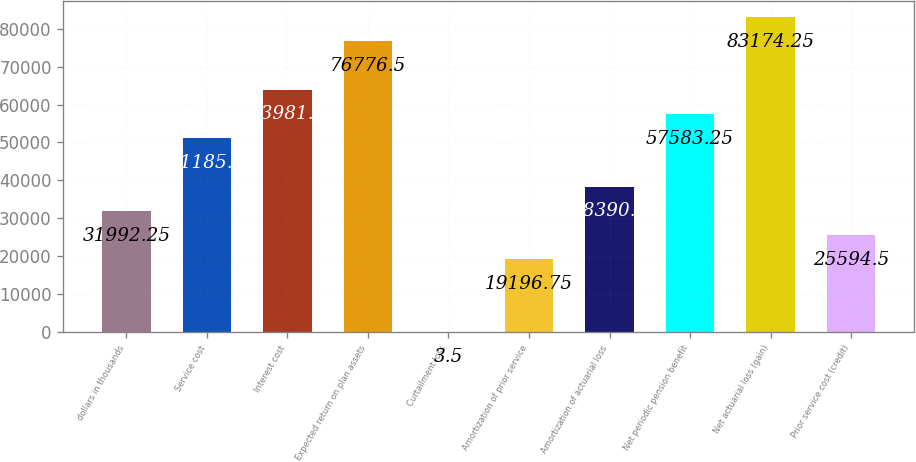<chart> <loc_0><loc_0><loc_500><loc_500><bar_chart><fcel>dollars in thousands<fcel>Service cost<fcel>Interest cost<fcel>Expected return on plan assets<fcel>Curtailment loss<fcel>Amortization of prior service<fcel>Amortization of actuarial loss<fcel>Net periodic pension benefit<fcel>Net actuarial loss (gain)<fcel>Prior service cost (credit)<nl><fcel>31992.2<fcel>51185.5<fcel>63981<fcel>76776.5<fcel>3.5<fcel>19196.8<fcel>38390<fcel>57583.2<fcel>83174.2<fcel>25594.5<nl></chart> 